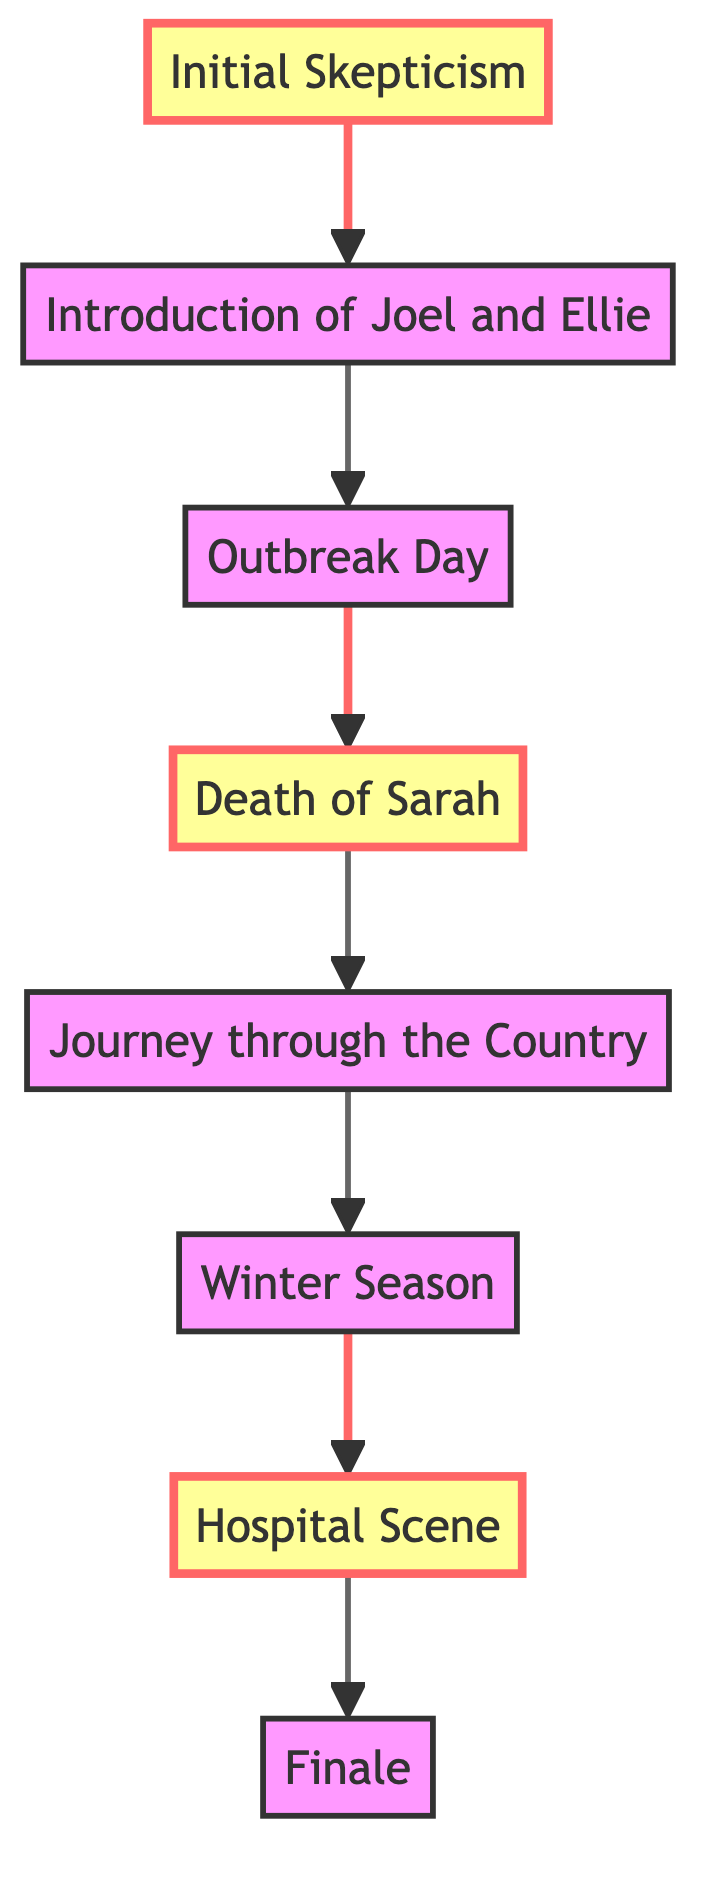What is the first plot point in the flow? The first plot point is "Initial Skepticism". It is the starting point of the flow chart, indicating the initial doubts about the TV adaptation.
Answer: Initial Skepticism How many nodes are in the diagram? There are eight nodes represented in the diagram, which include critical plot points from both the game and the TV adaptation.
Answer: 8 What is the final plot point in the flow? The final plot point is "Finale". It concludes the journey and solidifies the bond between Joel and Ellie.
Answer: Finale Which plot point directly follows "Death of Sarah"? The plot point that directly follows "Death of Sarah" is "Journey through the Country". This indicates the progression of the story after this pivotal emotional moment.
Answer: Journey through the Country Is "Hospital Scene" a highlight in the diagram? Yes, "Hospital Scene" is marked as a highlight in the diagram, indicating its significance in the narrative where Joel makes a critical decision.
Answer: Yes What plot point comes immediately before "Winter Season"? "Journey through the Country" comes immediately before "Winter Season". This depicts the sequence of events leading up to the winter aspects of the story.
Answer: Journey through the Country Which two plot points are highlighted in the diagram? The highlighted plot points are "Death of Sarah" and "Hospital Scene". These points are critical emotional moments in the storyline.
Answer: Death of Sarah, Hospital Scene How does "Introduction of Joel and Ellie" relate to "Outbreak Day"? "Introduction of Joel and Ellie" directly leads to "Outbreak Day", indicating that the characters' introduction happens before the outbreak event.
Answer: Leads to 